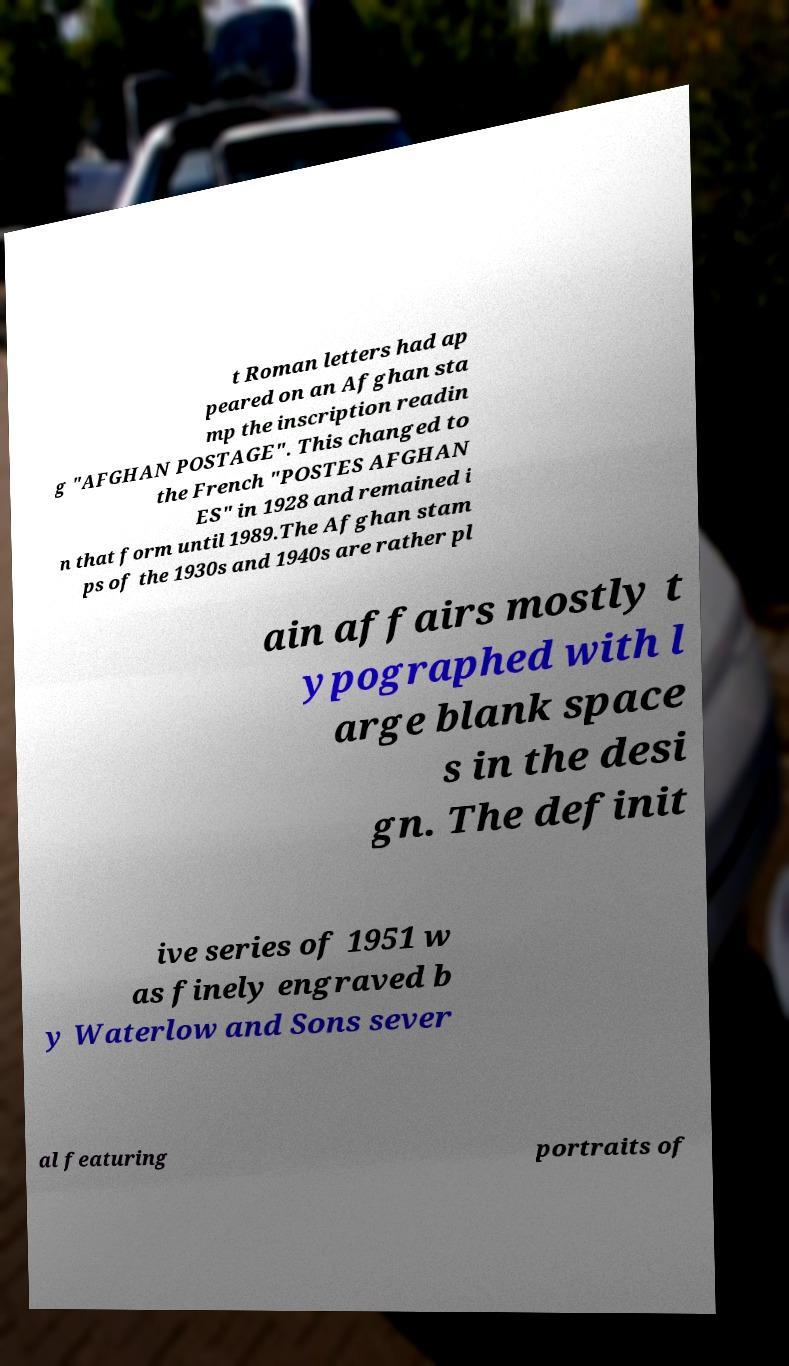Please read and relay the text visible in this image. What does it say? t Roman letters had ap peared on an Afghan sta mp the inscription readin g "AFGHAN POSTAGE". This changed to the French "POSTES AFGHAN ES" in 1928 and remained i n that form until 1989.The Afghan stam ps of the 1930s and 1940s are rather pl ain affairs mostly t ypographed with l arge blank space s in the desi gn. The definit ive series of 1951 w as finely engraved b y Waterlow and Sons sever al featuring portraits of 